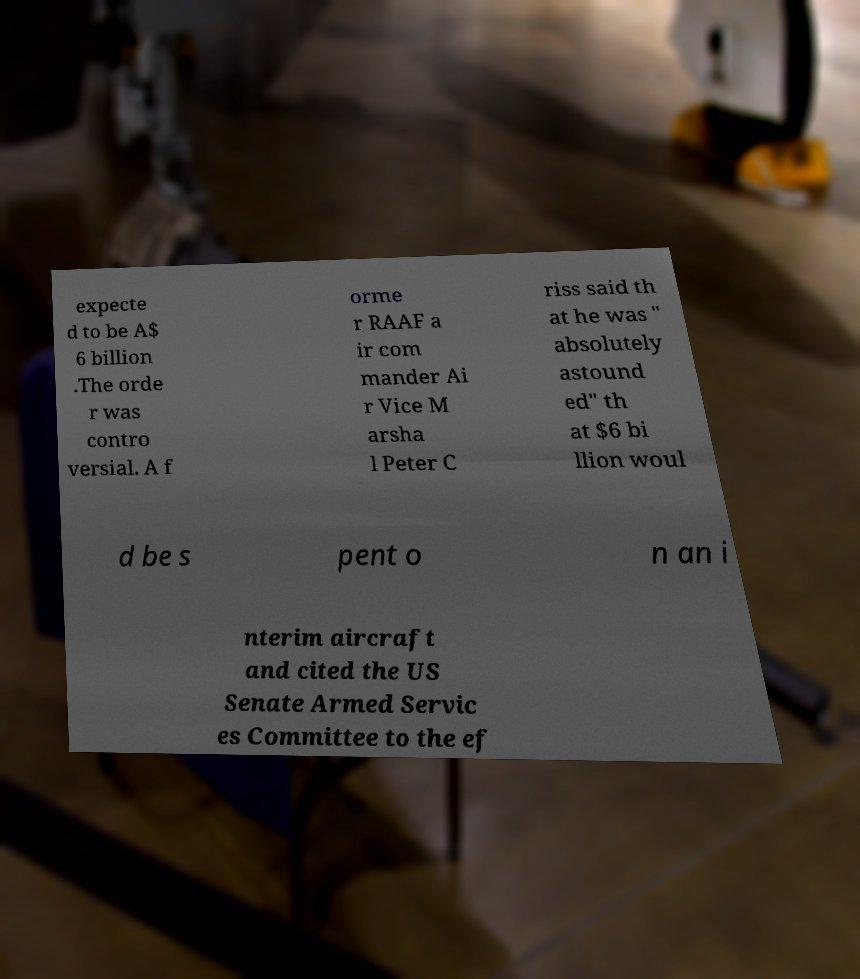Could you extract and type out the text from this image? expecte d to be A$ 6 billion .The orde r was contro versial. A f orme r RAAF a ir com mander Ai r Vice M arsha l Peter C riss said th at he was " absolutely astound ed" th at $6 bi llion woul d be s pent o n an i nterim aircraft and cited the US Senate Armed Servic es Committee to the ef 